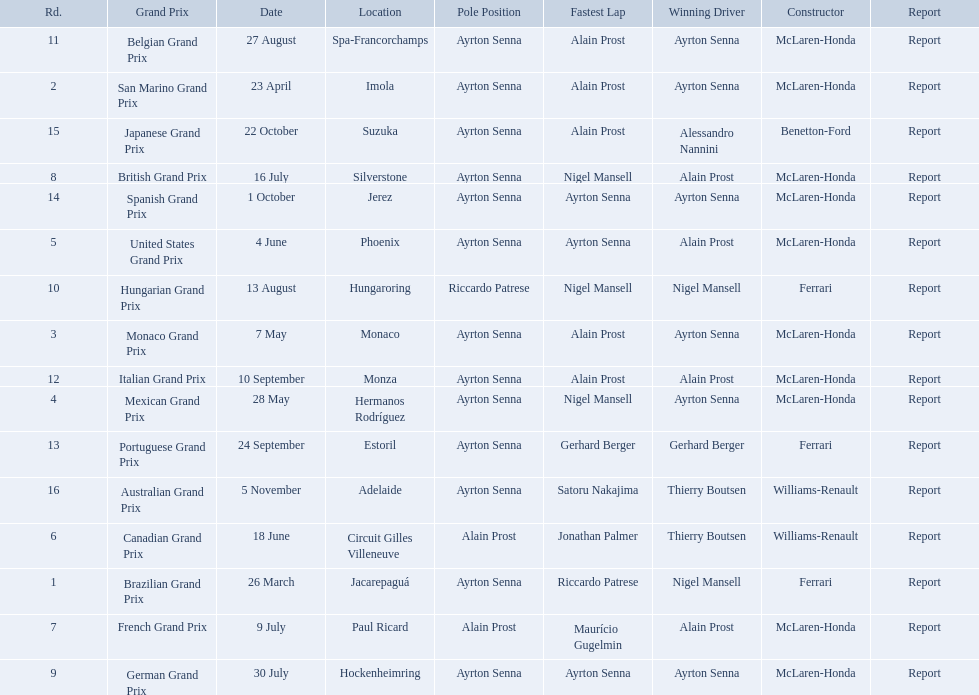What are all of the grand prix run in the 1989 formula one season? Brazilian Grand Prix, San Marino Grand Prix, Monaco Grand Prix, Mexican Grand Prix, United States Grand Prix, Canadian Grand Prix, French Grand Prix, British Grand Prix, German Grand Prix, Hungarian Grand Prix, Belgian Grand Prix, Italian Grand Prix, Portuguese Grand Prix, Spanish Grand Prix, Japanese Grand Prix, Australian Grand Prix. Of those 1989 formula one grand prix, which were run in october? Spanish Grand Prix, Japanese Grand Prix, Australian Grand Prix. Of those 1989 formula one grand prix run in october, which was the only one to be won by benetton-ford? Japanese Grand Prix. Who are the constructors in the 1989 formula one season? Ferrari, McLaren-Honda, McLaren-Honda, McLaren-Honda, McLaren-Honda, Williams-Renault, McLaren-Honda, McLaren-Honda, McLaren-Honda, Ferrari, McLaren-Honda, McLaren-Honda, Ferrari, McLaren-Honda, Benetton-Ford, Williams-Renault. On what date was bennington ford the constructor? 22 October. What was the race on october 22? Japanese Grand Prix. 